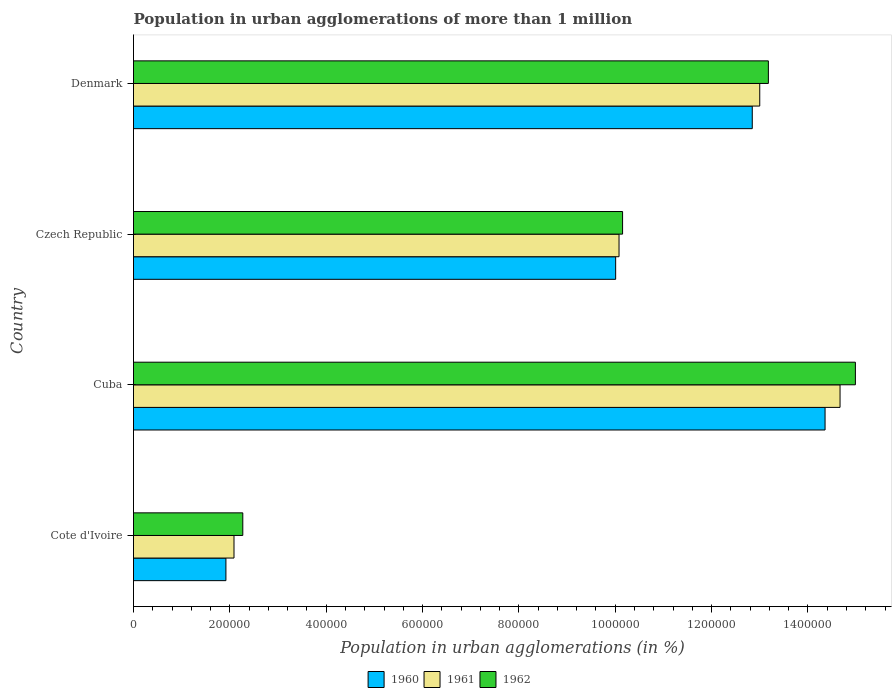How many different coloured bars are there?
Give a very brief answer. 3. Are the number of bars per tick equal to the number of legend labels?
Offer a terse response. Yes. How many bars are there on the 1st tick from the top?
Make the answer very short. 3. How many bars are there on the 4th tick from the bottom?
Ensure brevity in your answer.  3. What is the label of the 4th group of bars from the top?
Give a very brief answer. Cote d'Ivoire. In how many cases, is the number of bars for a given country not equal to the number of legend labels?
Your response must be concise. 0. What is the population in urban agglomerations in 1960 in Denmark?
Give a very brief answer. 1.28e+06. Across all countries, what is the maximum population in urban agglomerations in 1961?
Make the answer very short. 1.47e+06. Across all countries, what is the minimum population in urban agglomerations in 1962?
Give a very brief answer. 2.27e+05. In which country was the population in urban agglomerations in 1962 maximum?
Provide a succinct answer. Cuba. In which country was the population in urban agglomerations in 1961 minimum?
Offer a very short reply. Cote d'Ivoire. What is the total population in urban agglomerations in 1962 in the graph?
Keep it short and to the point. 4.06e+06. What is the difference between the population in urban agglomerations in 1961 in Cote d'Ivoire and that in Czech Republic?
Make the answer very short. -7.99e+05. What is the difference between the population in urban agglomerations in 1960 in Cuba and the population in urban agglomerations in 1962 in Cote d'Ivoire?
Offer a very short reply. 1.21e+06. What is the average population in urban agglomerations in 1961 per country?
Provide a short and direct response. 9.96e+05. What is the difference between the population in urban agglomerations in 1960 and population in urban agglomerations in 1961 in Czech Republic?
Keep it short and to the point. -7004. What is the ratio of the population in urban agglomerations in 1962 in Cuba to that in Denmark?
Give a very brief answer. 1.14. What is the difference between the highest and the second highest population in urban agglomerations in 1961?
Ensure brevity in your answer.  1.67e+05. What is the difference between the highest and the lowest population in urban agglomerations in 1961?
Give a very brief answer. 1.26e+06. Is the sum of the population in urban agglomerations in 1960 in Cote d'Ivoire and Denmark greater than the maximum population in urban agglomerations in 1961 across all countries?
Provide a short and direct response. Yes. Is it the case that in every country, the sum of the population in urban agglomerations in 1961 and population in urban agglomerations in 1962 is greater than the population in urban agglomerations in 1960?
Your response must be concise. Yes. Are all the bars in the graph horizontal?
Ensure brevity in your answer.  Yes. What is the difference between two consecutive major ticks on the X-axis?
Keep it short and to the point. 2.00e+05. Are the values on the major ticks of X-axis written in scientific E-notation?
Ensure brevity in your answer.  No. Does the graph contain grids?
Your response must be concise. No. Where does the legend appear in the graph?
Your response must be concise. Bottom center. How are the legend labels stacked?
Provide a succinct answer. Horizontal. What is the title of the graph?
Your answer should be very brief. Population in urban agglomerations of more than 1 million. What is the label or title of the X-axis?
Give a very brief answer. Population in urban agglomerations (in %). What is the Population in urban agglomerations (in %) of 1960 in Cote d'Ivoire?
Offer a terse response. 1.92e+05. What is the Population in urban agglomerations (in %) of 1961 in Cote d'Ivoire?
Your answer should be very brief. 2.09e+05. What is the Population in urban agglomerations (in %) in 1962 in Cote d'Ivoire?
Your response must be concise. 2.27e+05. What is the Population in urban agglomerations (in %) of 1960 in Cuba?
Ensure brevity in your answer.  1.44e+06. What is the Population in urban agglomerations (in %) in 1961 in Cuba?
Your answer should be compact. 1.47e+06. What is the Population in urban agglomerations (in %) of 1962 in Cuba?
Give a very brief answer. 1.50e+06. What is the Population in urban agglomerations (in %) of 1960 in Czech Republic?
Offer a terse response. 1.00e+06. What is the Population in urban agglomerations (in %) of 1961 in Czech Republic?
Keep it short and to the point. 1.01e+06. What is the Population in urban agglomerations (in %) in 1962 in Czech Republic?
Provide a short and direct response. 1.02e+06. What is the Population in urban agglomerations (in %) in 1960 in Denmark?
Your answer should be compact. 1.28e+06. What is the Population in urban agglomerations (in %) of 1961 in Denmark?
Your response must be concise. 1.30e+06. What is the Population in urban agglomerations (in %) of 1962 in Denmark?
Your response must be concise. 1.32e+06. Across all countries, what is the maximum Population in urban agglomerations (in %) of 1960?
Offer a terse response. 1.44e+06. Across all countries, what is the maximum Population in urban agglomerations (in %) in 1961?
Offer a very short reply. 1.47e+06. Across all countries, what is the maximum Population in urban agglomerations (in %) in 1962?
Your answer should be compact. 1.50e+06. Across all countries, what is the minimum Population in urban agglomerations (in %) in 1960?
Offer a very short reply. 1.92e+05. Across all countries, what is the minimum Population in urban agglomerations (in %) in 1961?
Keep it short and to the point. 2.09e+05. Across all countries, what is the minimum Population in urban agglomerations (in %) of 1962?
Offer a terse response. 2.27e+05. What is the total Population in urban agglomerations (in %) in 1960 in the graph?
Offer a terse response. 3.91e+06. What is the total Population in urban agglomerations (in %) in 1961 in the graph?
Provide a short and direct response. 3.98e+06. What is the total Population in urban agglomerations (in %) of 1962 in the graph?
Offer a terse response. 4.06e+06. What is the difference between the Population in urban agglomerations (in %) in 1960 in Cote d'Ivoire and that in Cuba?
Keep it short and to the point. -1.24e+06. What is the difference between the Population in urban agglomerations (in %) in 1961 in Cote d'Ivoire and that in Cuba?
Your answer should be very brief. -1.26e+06. What is the difference between the Population in urban agglomerations (in %) of 1962 in Cote d'Ivoire and that in Cuba?
Offer a terse response. -1.27e+06. What is the difference between the Population in urban agglomerations (in %) of 1960 in Cote d'Ivoire and that in Czech Republic?
Your response must be concise. -8.09e+05. What is the difference between the Population in urban agglomerations (in %) in 1961 in Cote d'Ivoire and that in Czech Republic?
Offer a very short reply. -7.99e+05. What is the difference between the Population in urban agglomerations (in %) in 1962 in Cote d'Ivoire and that in Czech Republic?
Give a very brief answer. -7.88e+05. What is the difference between the Population in urban agglomerations (in %) in 1960 in Cote d'Ivoire and that in Denmark?
Keep it short and to the point. -1.09e+06. What is the difference between the Population in urban agglomerations (in %) of 1961 in Cote d'Ivoire and that in Denmark?
Keep it short and to the point. -1.09e+06. What is the difference between the Population in urban agglomerations (in %) in 1962 in Cote d'Ivoire and that in Denmark?
Give a very brief answer. -1.09e+06. What is the difference between the Population in urban agglomerations (in %) of 1960 in Cuba and that in Czech Republic?
Your answer should be very brief. 4.35e+05. What is the difference between the Population in urban agglomerations (in %) in 1961 in Cuba and that in Czech Republic?
Offer a very short reply. 4.59e+05. What is the difference between the Population in urban agglomerations (in %) in 1962 in Cuba and that in Czech Republic?
Ensure brevity in your answer.  4.83e+05. What is the difference between the Population in urban agglomerations (in %) in 1960 in Cuba and that in Denmark?
Make the answer very short. 1.51e+05. What is the difference between the Population in urban agglomerations (in %) of 1961 in Cuba and that in Denmark?
Your answer should be compact. 1.67e+05. What is the difference between the Population in urban agglomerations (in %) of 1962 in Cuba and that in Denmark?
Your answer should be compact. 1.81e+05. What is the difference between the Population in urban agglomerations (in %) of 1960 in Czech Republic and that in Denmark?
Your response must be concise. -2.84e+05. What is the difference between the Population in urban agglomerations (in %) in 1961 in Czech Republic and that in Denmark?
Make the answer very short. -2.92e+05. What is the difference between the Population in urban agglomerations (in %) of 1962 in Czech Republic and that in Denmark?
Provide a short and direct response. -3.03e+05. What is the difference between the Population in urban agglomerations (in %) of 1960 in Cote d'Ivoire and the Population in urban agglomerations (in %) of 1961 in Cuba?
Make the answer very short. -1.27e+06. What is the difference between the Population in urban agglomerations (in %) of 1960 in Cote d'Ivoire and the Population in urban agglomerations (in %) of 1962 in Cuba?
Your response must be concise. -1.31e+06. What is the difference between the Population in urban agglomerations (in %) of 1961 in Cote d'Ivoire and the Population in urban agglomerations (in %) of 1962 in Cuba?
Offer a terse response. -1.29e+06. What is the difference between the Population in urban agglomerations (in %) of 1960 in Cote d'Ivoire and the Population in urban agglomerations (in %) of 1961 in Czech Republic?
Keep it short and to the point. -8.16e+05. What is the difference between the Population in urban agglomerations (in %) in 1960 in Cote d'Ivoire and the Population in urban agglomerations (in %) in 1962 in Czech Republic?
Keep it short and to the point. -8.23e+05. What is the difference between the Population in urban agglomerations (in %) in 1961 in Cote d'Ivoire and the Population in urban agglomerations (in %) in 1962 in Czech Republic?
Keep it short and to the point. -8.07e+05. What is the difference between the Population in urban agglomerations (in %) of 1960 in Cote d'Ivoire and the Population in urban agglomerations (in %) of 1961 in Denmark?
Offer a very short reply. -1.11e+06. What is the difference between the Population in urban agglomerations (in %) in 1960 in Cote d'Ivoire and the Population in urban agglomerations (in %) in 1962 in Denmark?
Your response must be concise. -1.13e+06. What is the difference between the Population in urban agglomerations (in %) of 1961 in Cote d'Ivoire and the Population in urban agglomerations (in %) of 1962 in Denmark?
Provide a succinct answer. -1.11e+06. What is the difference between the Population in urban agglomerations (in %) of 1960 in Cuba and the Population in urban agglomerations (in %) of 1961 in Czech Republic?
Ensure brevity in your answer.  4.28e+05. What is the difference between the Population in urban agglomerations (in %) in 1960 in Cuba and the Population in urban agglomerations (in %) in 1962 in Czech Republic?
Your answer should be compact. 4.20e+05. What is the difference between the Population in urban agglomerations (in %) of 1961 in Cuba and the Population in urban agglomerations (in %) of 1962 in Czech Republic?
Make the answer very short. 4.51e+05. What is the difference between the Population in urban agglomerations (in %) in 1960 in Cuba and the Population in urban agglomerations (in %) in 1961 in Denmark?
Your answer should be compact. 1.36e+05. What is the difference between the Population in urban agglomerations (in %) in 1960 in Cuba and the Population in urban agglomerations (in %) in 1962 in Denmark?
Give a very brief answer. 1.18e+05. What is the difference between the Population in urban agglomerations (in %) of 1961 in Cuba and the Population in urban agglomerations (in %) of 1962 in Denmark?
Give a very brief answer. 1.49e+05. What is the difference between the Population in urban agglomerations (in %) in 1960 in Czech Republic and the Population in urban agglomerations (in %) in 1961 in Denmark?
Ensure brevity in your answer.  -2.99e+05. What is the difference between the Population in urban agglomerations (in %) in 1960 in Czech Republic and the Population in urban agglomerations (in %) in 1962 in Denmark?
Offer a very short reply. -3.17e+05. What is the difference between the Population in urban agglomerations (in %) in 1961 in Czech Republic and the Population in urban agglomerations (in %) in 1962 in Denmark?
Keep it short and to the point. -3.10e+05. What is the average Population in urban agglomerations (in %) in 1960 per country?
Make the answer very short. 9.78e+05. What is the average Population in urban agglomerations (in %) in 1961 per country?
Offer a terse response. 9.96e+05. What is the average Population in urban agglomerations (in %) in 1962 per country?
Offer a terse response. 1.01e+06. What is the difference between the Population in urban agglomerations (in %) in 1960 and Population in urban agglomerations (in %) in 1961 in Cote d'Ivoire?
Offer a very short reply. -1.68e+04. What is the difference between the Population in urban agglomerations (in %) in 1960 and Population in urban agglomerations (in %) in 1962 in Cote d'Ivoire?
Your answer should be compact. -3.50e+04. What is the difference between the Population in urban agglomerations (in %) in 1961 and Population in urban agglomerations (in %) in 1962 in Cote d'Ivoire?
Offer a very short reply. -1.82e+04. What is the difference between the Population in urban agglomerations (in %) in 1960 and Population in urban agglomerations (in %) in 1961 in Cuba?
Offer a very short reply. -3.11e+04. What is the difference between the Population in urban agglomerations (in %) of 1960 and Population in urban agglomerations (in %) of 1962 in Cuba?
Give a very brief answer. -6.30e+04. What is the difference between the Population in urban agglomerations (in %) of 1961 and Population in urban agglomerations (in %) of 1962 in Cuba?
Your answer should be compact. -3.18e+04. What is the difference between the Population in urban agglomerations (in %) of 1960 and Population in urban agglomerations (in %) of 1961 in Czech Republic?
Offer a terse response. -7004. What is the difference between the Population in urban agglomerations (in %) in 1960 and Population in urban agglomerations (in %) in 1962 in Czech Republic?
Ensure brevity in your answer.  -1.44e+04. What is the difference between the Population in urban agglomerations (in %) of 1961 and Population in urban agglomerations (in %) of 1962 in Czech Republic?
Offer a terse response. -7379. What is the difference between the Population in urban agglomerations (in %) of 1960 and Population in urban agglomerations (in %) of 1961 in Denmark?
Make the answer very short. -1.55e+04. What is the difference between the Population in urban agglomerations (in %) of 1960 and Population in urban agglomerations (in %) of 1962 in Denmark?
Your response must be concise. -3.34e+04. What is the difference between the Population in urban agglomerations (in %) in 1961 and Population in urban agglomerations (in %) in 1962 in Denmark?
Provide a short and direct response. -1.79e+04. What is the ratio of the Population in urban agglomerations (in %) of 1960 in Cote d'Ivoire to that in Cuba?
Provide a short and direct response. 0.13. What is the ratio of the Population in urban agglomerations (in %) in 1961 in Cote d'Ivoire to that in Cuba?
Ensure brevity in your answer.  0.14. What is the ratio of the Population in urban agglomerations (in %) in 1962 in Cote d'Ivoire to that in Cuba?
Offer a very short reply. 0.15. What is the ratio of the Population in urban agglomerations (in %) in 1960 in Cote d'Ivoire to that in Czech Republic?
Make the answer very short. 0.19. What is the ratio of the Population in urban agglomerations (in %) of 1961 in Cote d'Ivoire to that in Czech Republic?
Provide a short and direct response. 0.21. What is the ratio of the Population in urban agglomerations (in %) in 1962 in Cote d'Ivoire to that in Czech Republic?
Provide a succinct answer. 0.22. What is the ratio of the Population in urban agglomerations (in %) of 1960 in Cote d'Ivoire to that in Denmark?
Offer a very short reply. 0.15. What is the ratio of the Population in urban agglomerations (in %) in 1961 in Cote d'Ivoire to that in Denmark?
Give a very brief answer. 0.16. What is the ratio of the Population in urban agglomerations (in %) in 1962 in Cote d'Ivoire to that in Denmark?
Make the answer very short. 0.17. What is the ratio of the Population in urban agglomerations (in %) of 1960 in Cuba to that in Czech Republic?
Ensure brevity in your answer.  1.43. What is the ratio of the Population in urban agglomerations (in %) in 1961 in Cuba to that in Czech Republic?
Your answer should be very brief. 1.46. What is the ratio of the Population in urban agglomerations (in %) of 1962 in Cuba to that in Czech Republic?
Offer a terse response. 1.48. What is the ratio of the Population in urban agglomerations (in %) of 1960 in Cuba to that in Denmark?
Your answer should be compact. 1.12. What is the ratio of the Population in urban agglomerations (in %) in 1961 in Cuba to that in Denmark?
Keep it short and to the point. 1.13. What is the ratio of the Population in urban agglomerations (in %) in 1962 in Cuba to that in Denmark?
Your answer should be very brief. 1.14. What is the ratio of the Population in urban agglomerations (in %) of 1960 in Czech Republic to that in Denmark?
Your answer should be very brief. 0.78. What is the ratio of the Population in urban agglomerations (in %) of 1961 in Czech Republic to that in Denmark?
Provide a succinct answer. 0.78. What is the ratio of the Population in urban agglomerations (in %) in 1962 in Czech Republic to that in Denmark?
Keep it short and to the point. 0.77. What is the difference between the highest and the second highest Population in urban agglomerations (in %) of 1960?
Make the answer very short. 1.51e+05. What is the difference between the highest and the second highest Population in urban agglomerations (in %) of 1961?
Offer a terse response. 1.67e+05. What is the difference between the highest and the second highest Population in urban agglomerations (in %) of 1962?
Offer a very short reply. 1.81e+05. What is the difference between the highest and the lowest Population in urban agglomerations (in %) of 1960?
Provide a short and direct response. 1.24e+06. What is the difference between the highest and the lowest Population in urban agglomerations (in %) of 1961?
Keep it short and to the point. 1.26e+06. What is the difference between the highest and the lowest Population in urban agglomerations (in %) of 1962?
Give a very brief answer. 1.27e+06. 